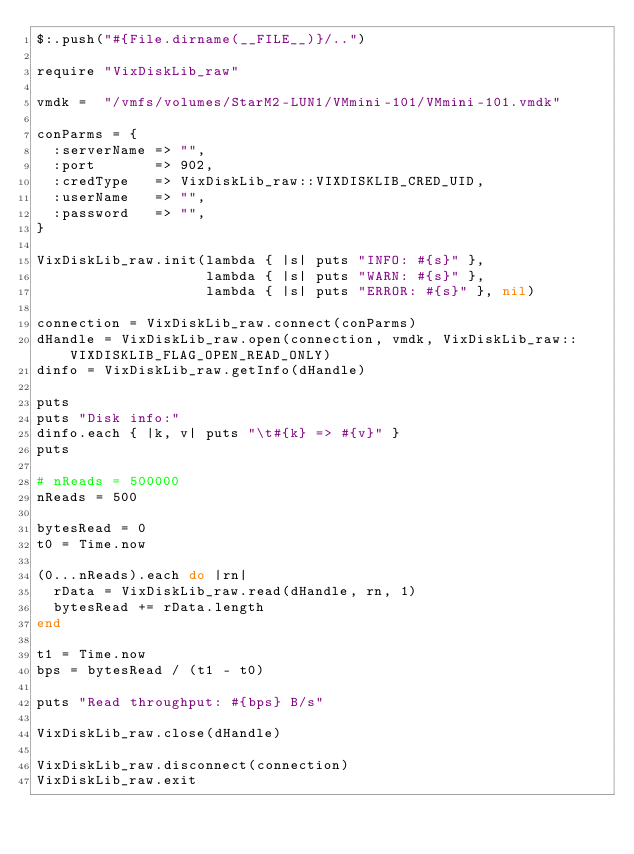Convert code to text. <code><loc_0><loc_0><loc_500><loc_500><_Ruby_>$:.push("#{File.dirname(__FILE__)}/..")

require "VixDiskLib_raw"

vmdk =  "/vmfs/volumes/StarM2-LUN1/VMmini-101/VMmini-101.vmdk"

conParms = {
  :serverName => "",
  :port       => 902,
  :credType   => VixDiskLib_raw::VIXDISKLIB_CRED_UID,
  :userName   => "",
  :password   => "",
}

VixDiskLib_raw.init(lambda { |s| puts "INFO: #{s}" },
                    lambda { |s| puts "WARN: #{s}" },
                    lambda { |s| puts "ERROR: #{s}" }, nil)

connection = VixDiskLib_raw.connect(conParms)
dHandle = VixDiskLib_raw.open(connection, vmdk, VixDiskLib_raw::VIXDISKLIB_FLAG_OPEN_READ_ONLY)
dinfo = VixDiskLib_raw.getInfo(dHandle)

puts
puts "Disk info:"
dinfo.each { |k, v| puts "\t#{k} => #{v}" }
puts

# nReads = 500000
nReads = 500

bytesRead = 0
t0 = Time.now

(0...nReads).each do |rn|
  rData = VixDiskLib_raw.read(dHandle, rn, 1)
  bytesRead += rData.length
end

t1 = Time.now
bps = bytesRead / (t1 - t0)

puts "Read throughput: #{bps} B/s"

VixDiskLib_raw.close(dHandle)

VixDiskLib_raw.disconnect(connection)
VixDiskLib_raw.exit
</code> 